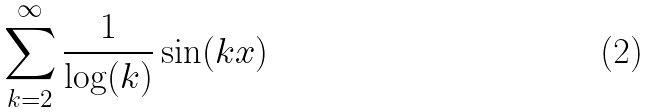Convert formula to latex. <formula><loc_0><loc_0><loc_500><loc_500>\sum _ { k = 2 } ^ { \infty } \frac { 1 } { \log ( k ) } \sin ( k x )</formula> 